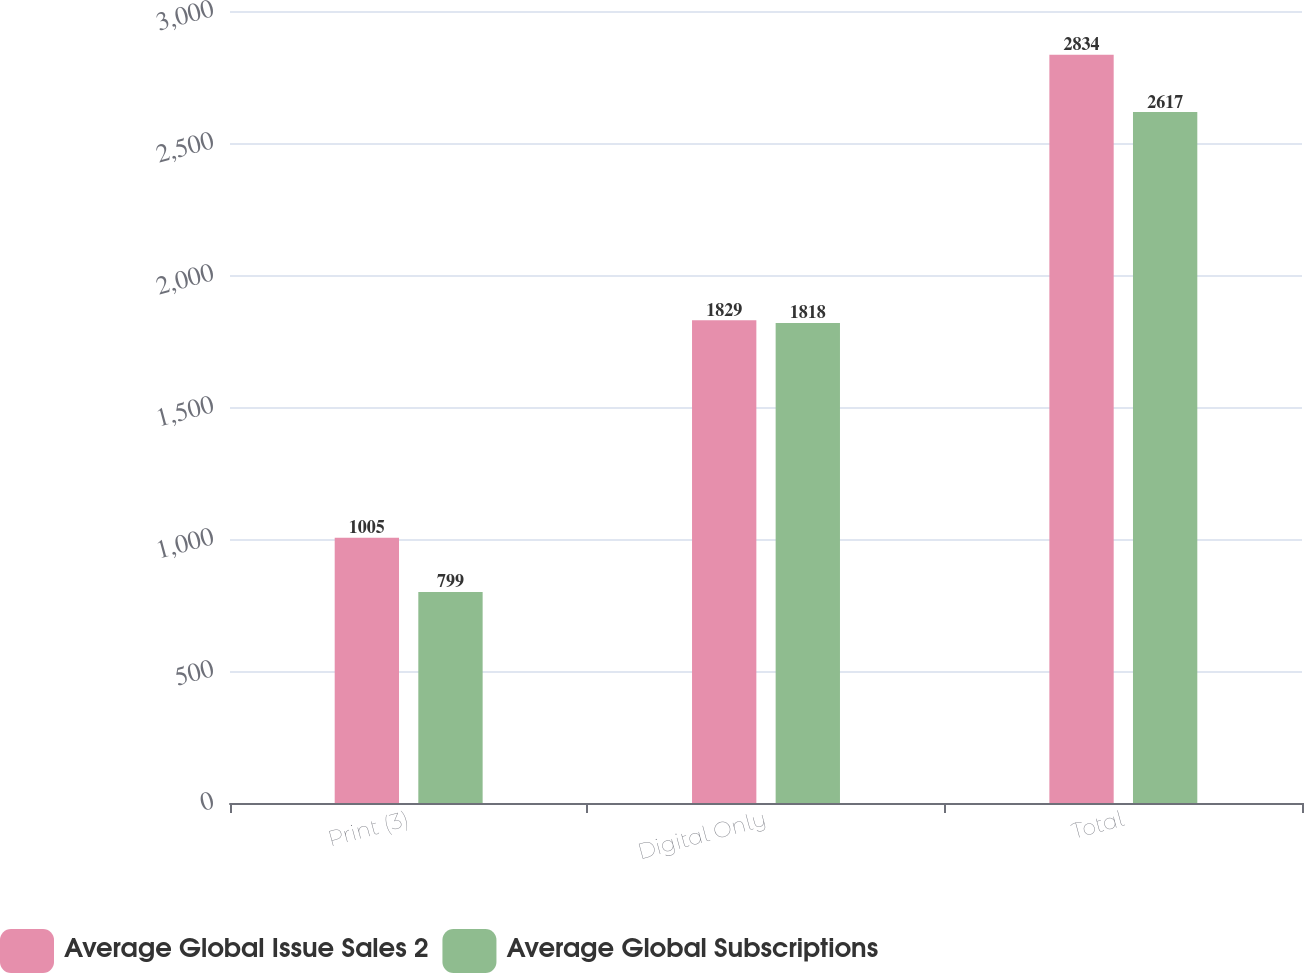<chart> <loc_0><loc_0><loc_500><loc_500><stacked_bar_chart><ecel><fcel>Print (3)<fcel>Digital Only<fcel>Total<nl><fcel>Average Global Issue Sales 2<fcel>1005<fcel>1829<fcel>2834<nl><fcel>Average Global Subscriptions<fcel>799<fcel>1818<fcel>2617<nl></chart> 